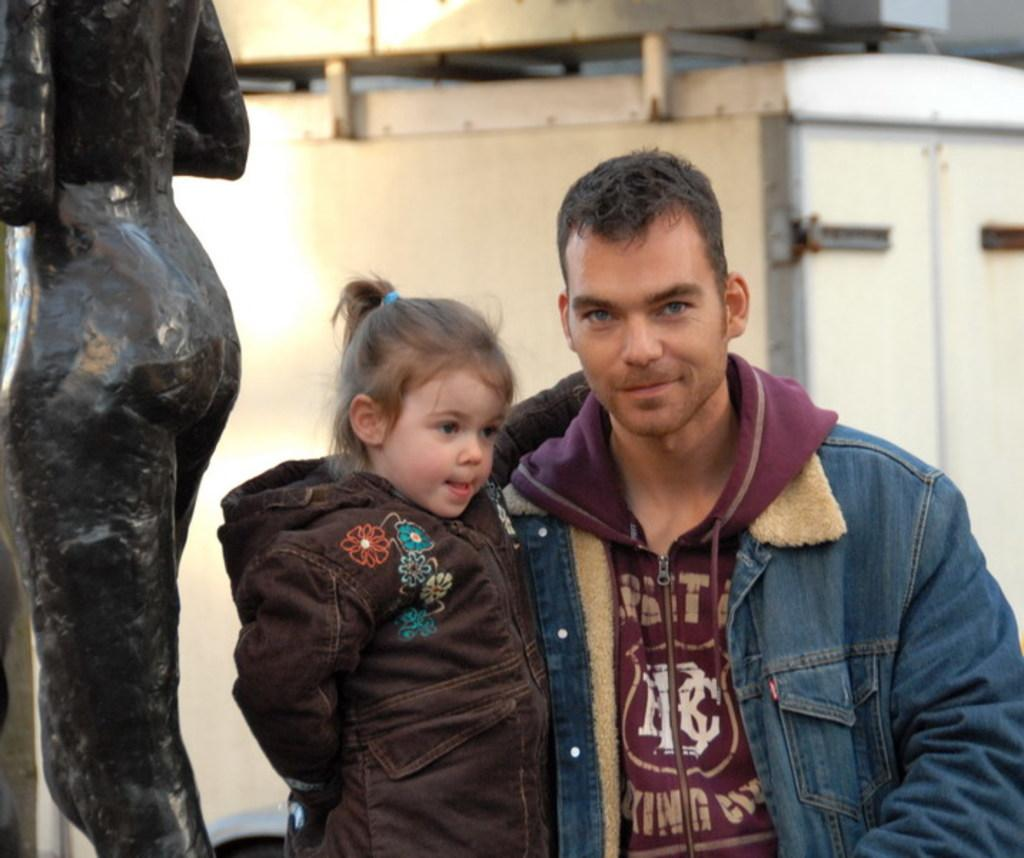Who is on the right side of the image? There is a man on the right side of the image. What is the man doing in the image? The man is holding a kid. What can be seen on the left side of the image? There is a statue on the left side of the image. What is visible in the background of the image? There is a machine visible in the background of the image. What color of paint is being used to observe the man and the kid in the image? There is no paint or observation process depicted in the image; it is a photograph or illustration. 